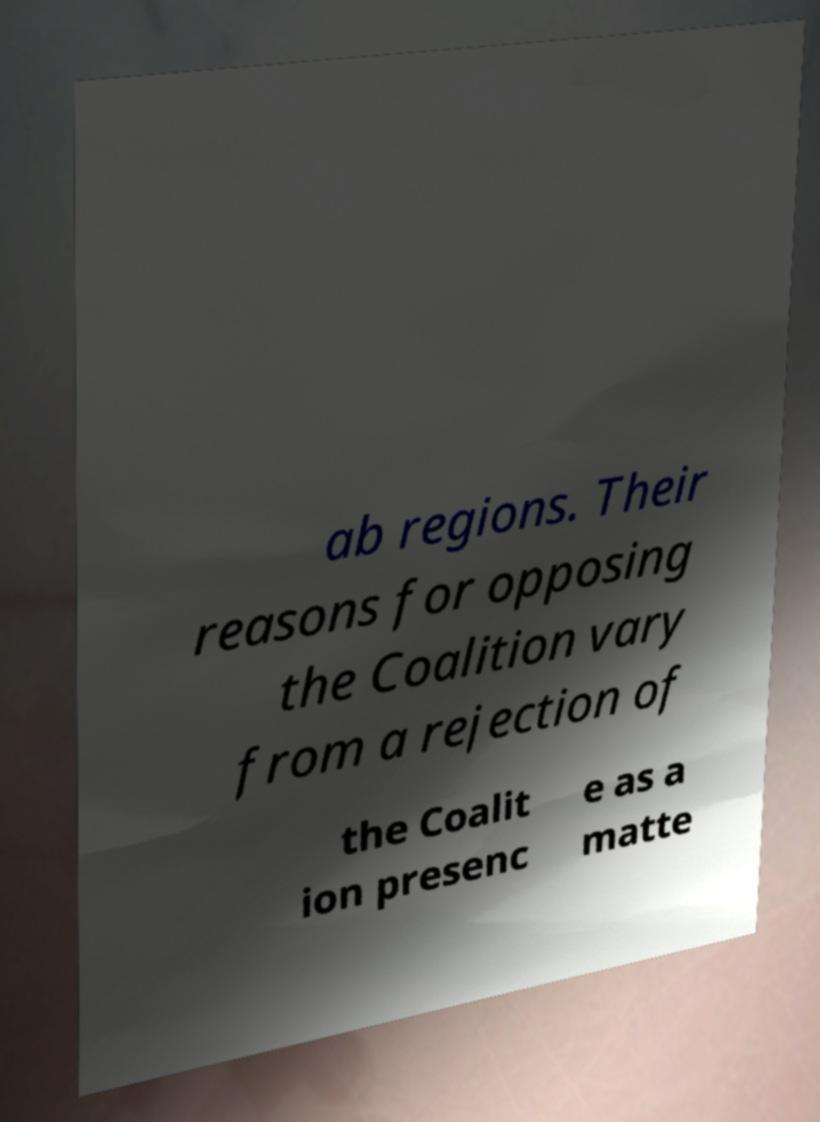What messages or text are displayed in this image? I need them in a readable, typed format. ab regions. Their reasons for opposing the Coalition vary from a rejection of the Coalit ion presenc e as a matte 